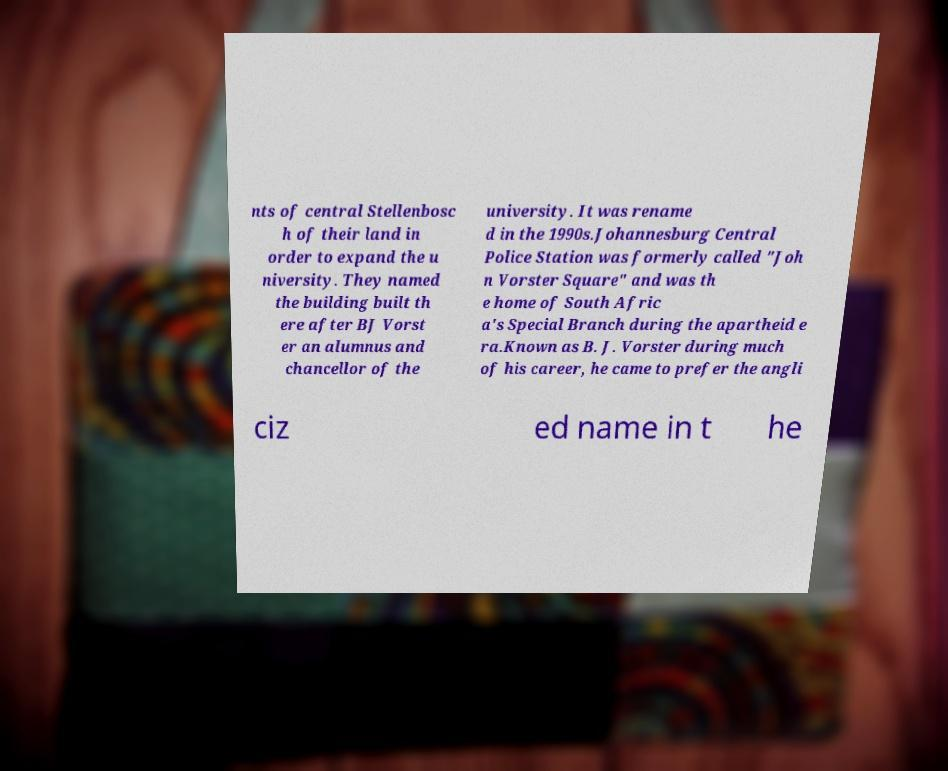I need the written content from this picture converted into text. Can you do that? nts of central Stellenbosc h of their land in order to expand the u niversity. They named the building built th ere after BJ Vorst er an alumnus and chancellor of the university. It was rename d in the 1990s.Johannesburg Central Police Station was formerly called "Joh n Vorster Square" and was th e home of South Afric a's Special Branch during the apartheid e ra.Known as B. J. Vorster during much of his career, he came to prefer the angli ciz ed name in t he 